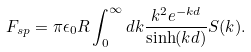<formula> <loc_0><loc_0><loc_500><loc_500>F _ { s p } = \pi \epsilon _ { 0 } R \int _ { 0 } ^ { \infty } d k \frac { k ^ { 2 } e ^ { - k d } } { \sinh ( k d ) } S ( k ) .</formula> 